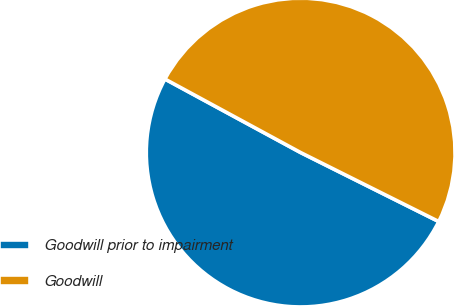Convert chart. <chart><loc_0><loc_0><loc_500><loc_500><pie_chart><fcel>Goodwill prior to impairment<fcel>Goodwill<nl><fcel>50.53%<fcel>49.47%<nl></chart> 